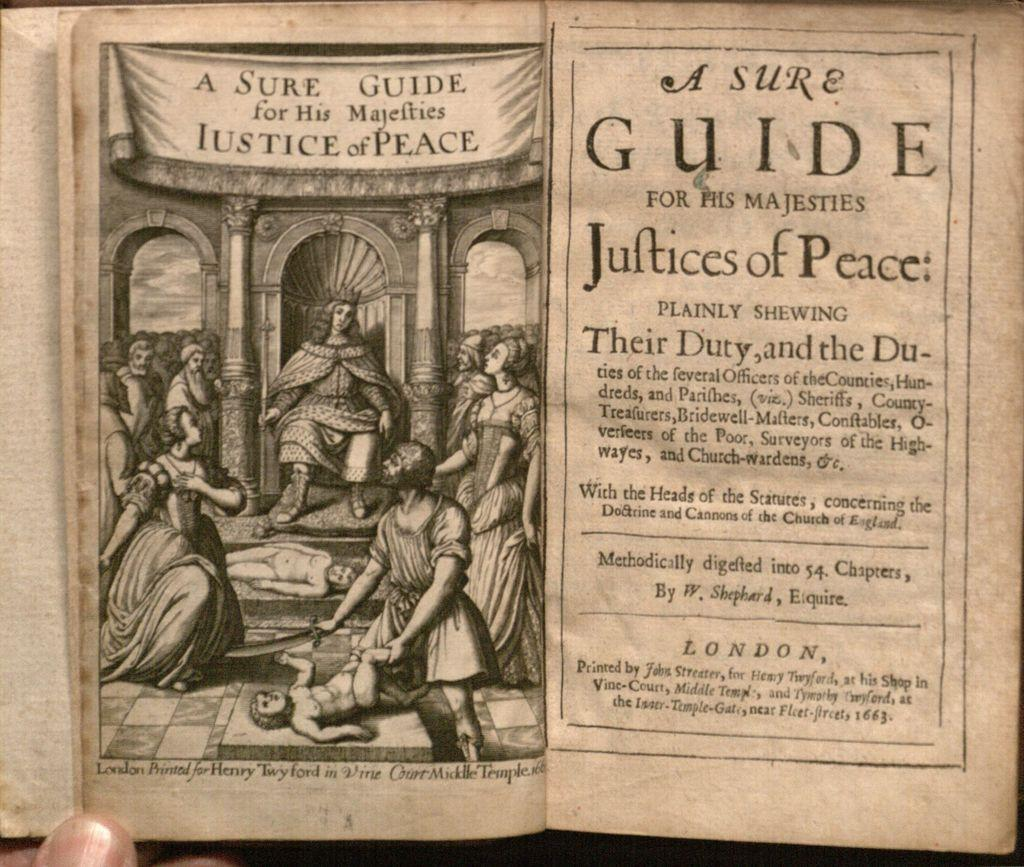<image>
Write a terse but informative summary of the picture. A book's title page says that it was published in London. 